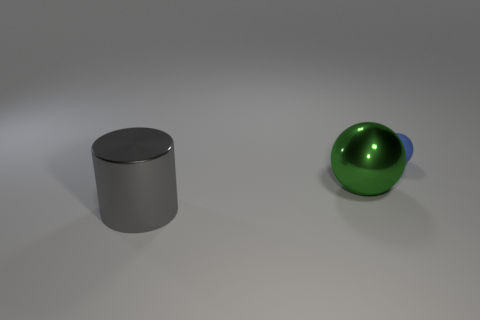Subtract all red cylinders. Subtract all cyan blocks. How many cylinders are left? 1 Add 3 green objects. How many objects exist? 6 Subtract all balls. How many objects are left? 1 Add 3 small yellow metal spheres. How many small yellow metal spheres exist? 3 Subtract 0 cyan balls. How many objects are left? 3 Subtract all blue spheres. Subtract all metallic balls. How many objects are left? 1 Add 2 big gray metallic things. How many big gray metallic things are left? 3 